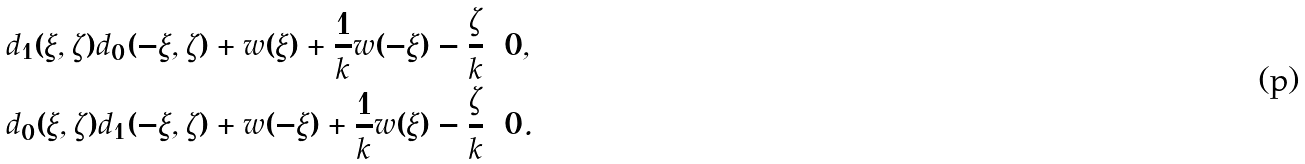<formula> <loc_0><loc_0><loc_500><loc_500>& d _ { 1 } ( \xi , \zeta ) d _ { 0 } ( - \xi , \zeta ) + w ( \xi ) + \frac { 1 } { k } w ( - \xi ) - \frac { \zeta } { k } = 0 , \\ & d _ { 0 } ( \xi , \zeta ) d _ { 1 } ( - \xi , \zeta ) + w ( - \xi ) + \frac { 1 } { k } w ( \xi ) - \frac { \zeta } { k } = 0 .</formula> 